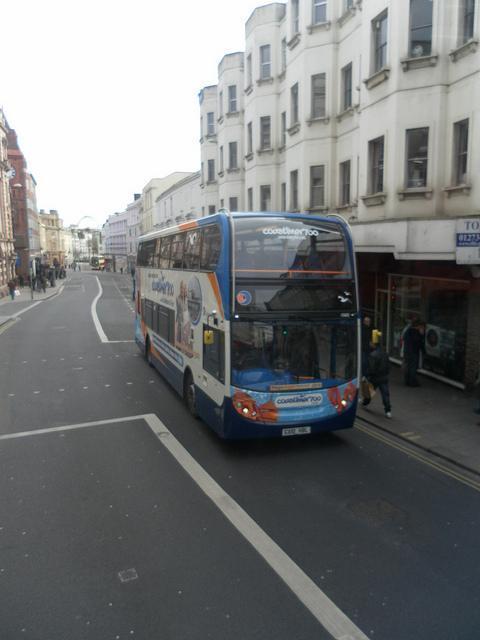How many stories does the bus have?q?
Give a very brief answer. 2. How many buses are on the street?
Give a very brief answer. 1. 